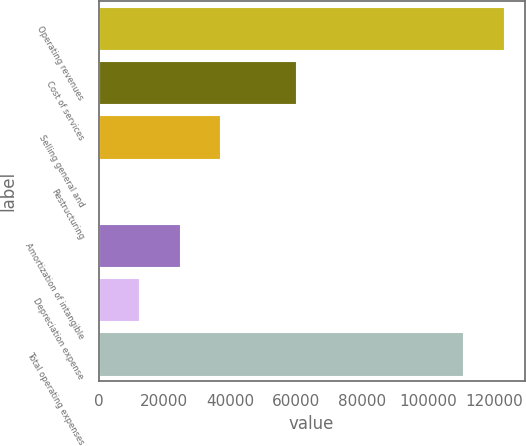Convert chart to OTSL. <chart><loc_0><loc_0><loc_500><loc_500><bar_chart><fcel>Operating revenues<fcel>Cost of services<fcel>Selling general and<fcel>Restructuring<fcel>Amortization of intangible<fcel>Depreciation expense<fcel>Total operating expenses<nl><fcel>123151<fcel>60003<fcel>36958.6<fcel>19<fcel>24645.4<fcel>12332.2<fcel>110762<nl></chart> 